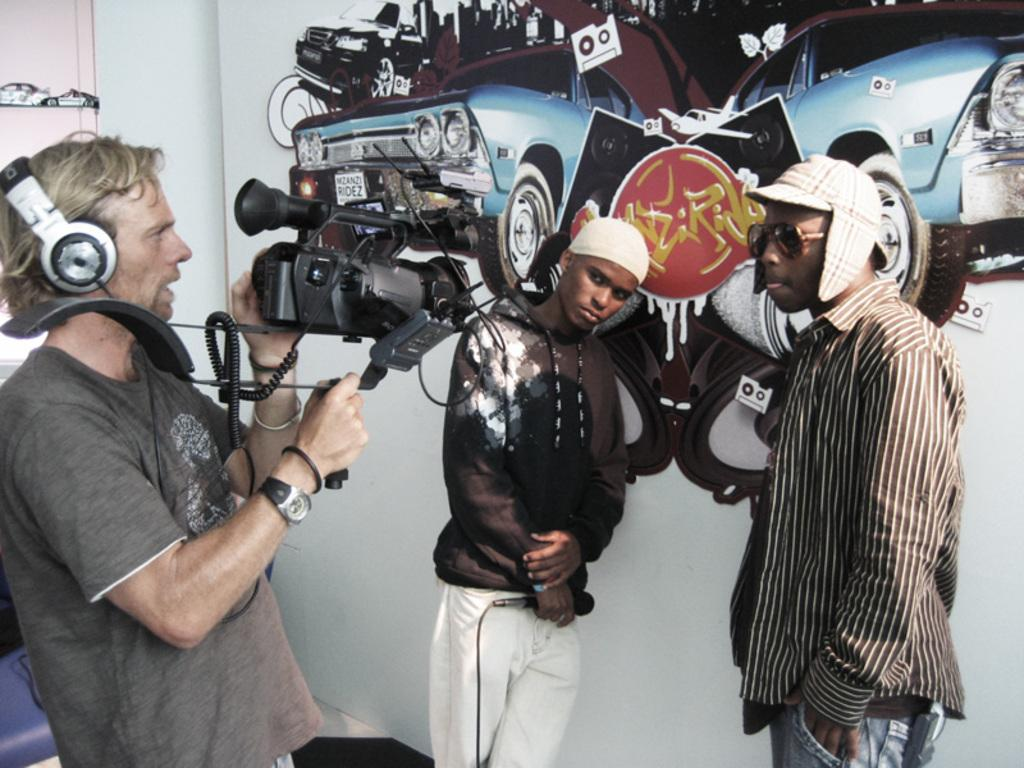How many people are in the image? There are two persons in the image. What are the two persons doing in the image? One person is holding a camera and shooting, while the other person is standing in front of a painted board. What is the purpose of the painted board in the image? The purpose of the painted board is not explicitly mentioned in the facts, but it could be a backdrop for the person being photographed. What is the belief of the circle in the image? There is no circle present in the image, and therefore no belief can be attributed to it. 